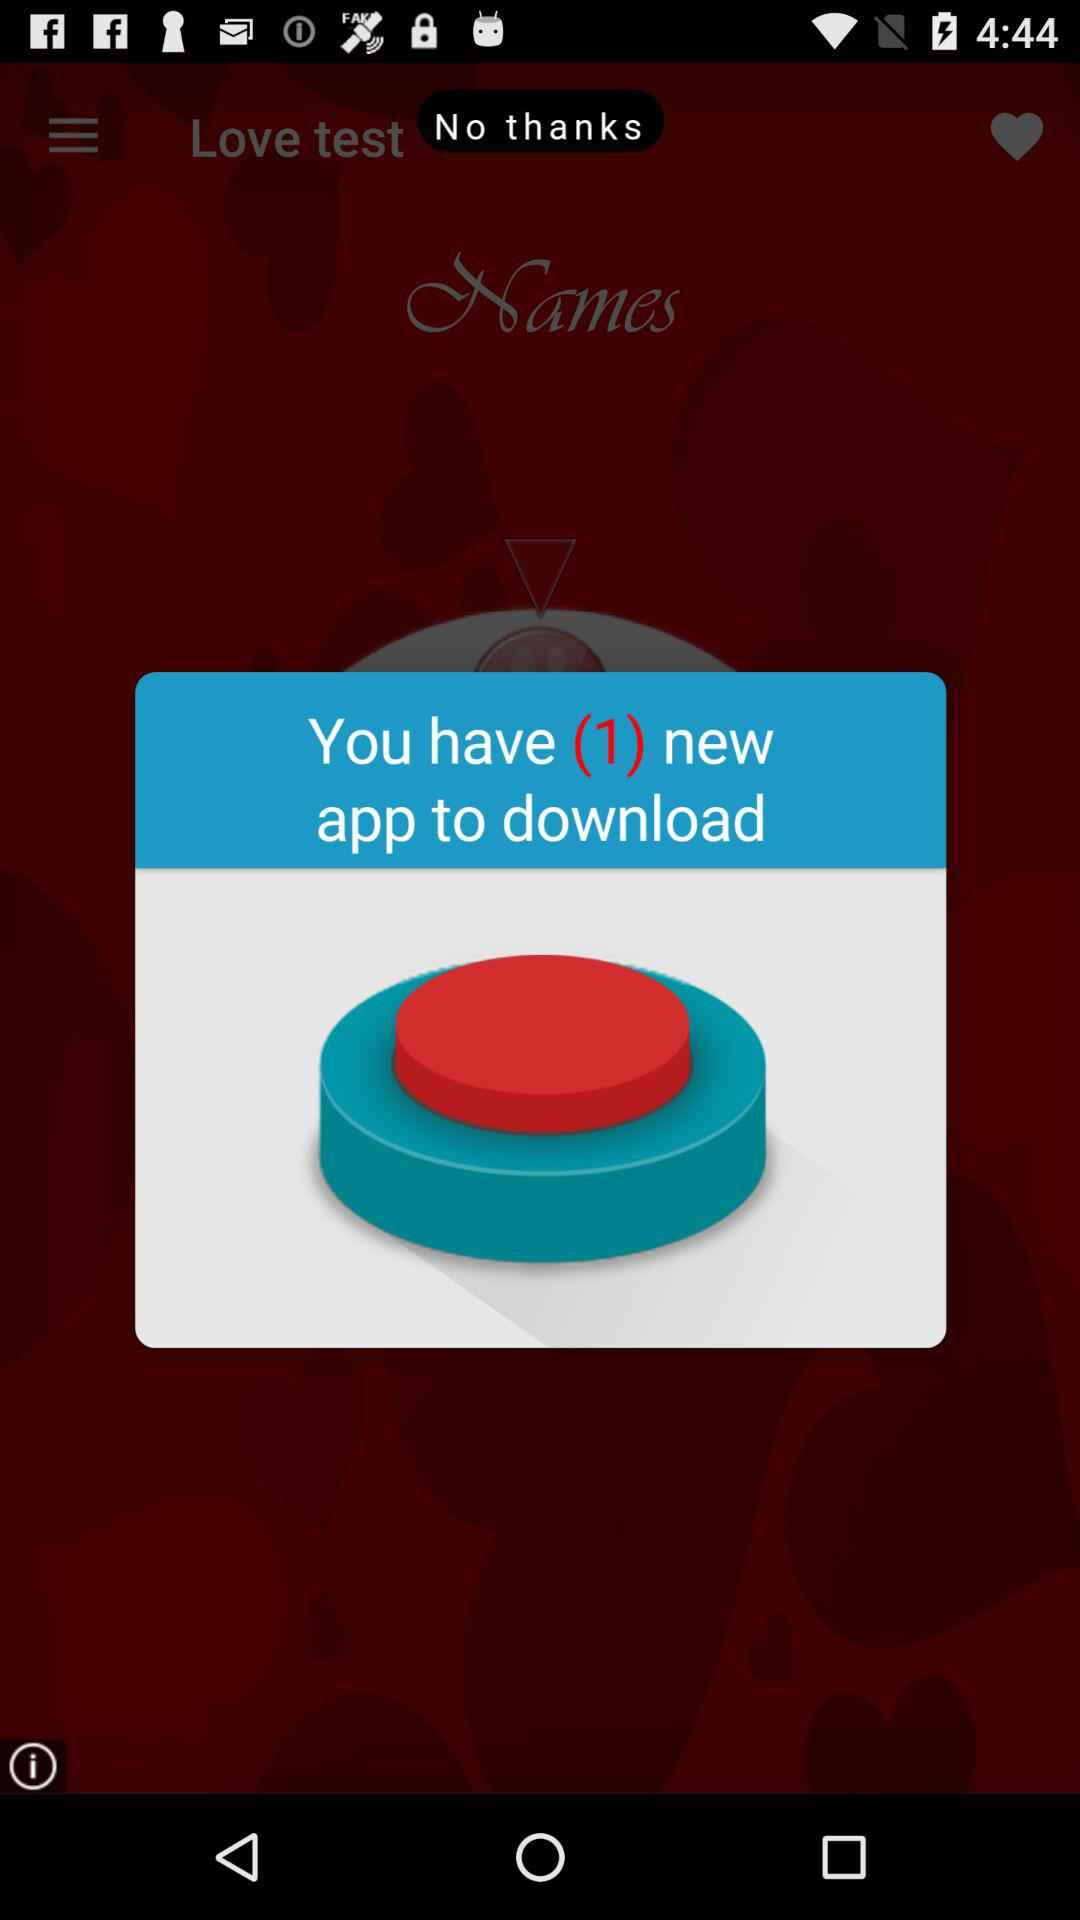What is the number of available apps to download? The number of available apps to download is 1. 